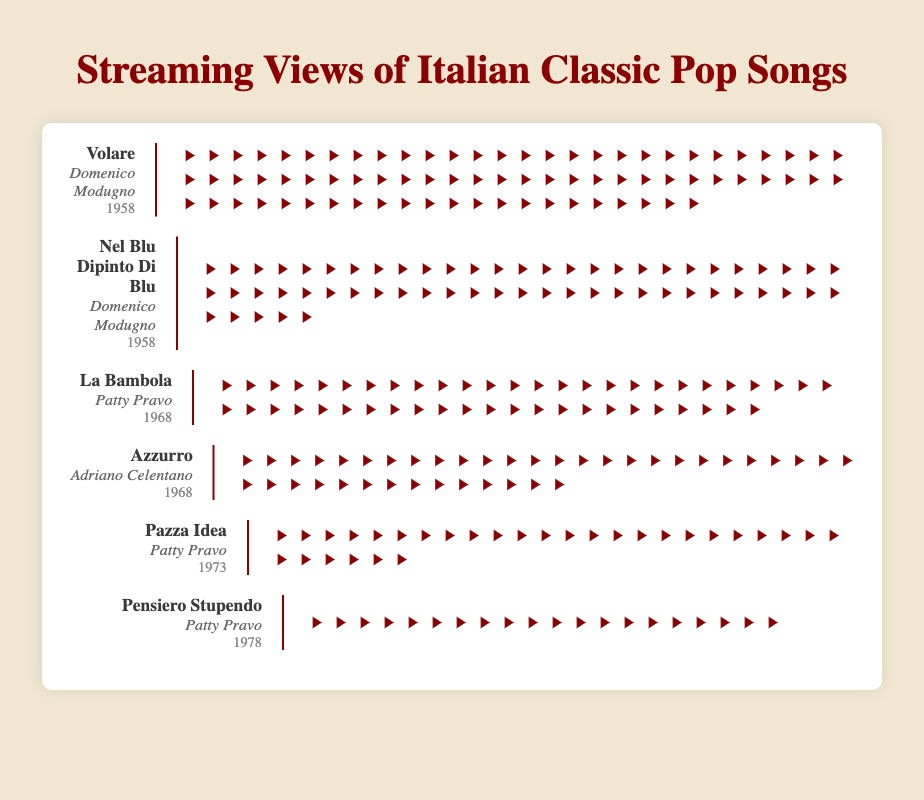How many play button icons represent views for "La Bambola"? The play button icons represent individual views and are grouped together for visual count. For "La Bambola," you can simply count the number of play button icons displayed in the figure.
Answer: 50 Which song by Patty Pravo has the least number of views? You need to look at the play button icons for each song by Patty Pravo to determine which one has the least views. Comparing all her songs, "Pensiero Stupendo" has the fewest play button icons.
Answer: Pensiero Stupendo In which year were the songs "La Bambola" and "Azzurro" released? The titles, artists, and years of release are shown clearly in the song information section of each song row. Both "La Bambola" by Patty Pravo and "Azzurro" by Adriano Celentano were released in 1968.
Answer: 1968 How many more views does "Volare" have compared to "Azzurro"? "Volare" has 80 play button icons while "Azzurro" has 40. By subtracting the icons of "Azzurro" from "Volare," you get 80 - 40 = 40 more icons. Each icon represents 100,000 views. Thus, 40 × 100,000 = 4,000,000 more views.
Answer: 4,000,000 Which song has the highest number of views? By observing the number of play button icons for each song, "Volare" by Domenico Modugno has the highest count, with 80 icons.
Answer: Volare What is the total number of views for songs released in 1958? Calculate the total number of views by adding the play button icons for 1958 releases, which include "Volare" (80 icons) and "Nel Blu Dipinto Di Blu" (60 icons). In total: 80 + 60 = 140 icons. Each icon represents 100,000 views. Thus, 140 × 100,000 = 14,000,000 views.
Answer: 14,000,000 What is the average number of views for Patty Pravo's songs shown in the figure? Count each song by Patty Pravo and their respective play button icons: "La Bambola" (50), "Pazza Idea" (30), and "Pensiero Stupendo" (20). Add the icons: 50 + 30 + 20 = 100. Divide by the number of songs, 100 / 3 = 33.33 icons, equivalent to 3,333,333 views on average.
Answer: 3,333,333 Which artist has the most aggregated views? Add the total play button icons for each artist and compare. Patty Pravo has 100, Domenico Modugno has 140, and Adriano Celentano has 40. Domenico Modugno has the most with 140 icons.
Answer: Domenico Modugno Is "Pensiero Stupendo" more popular than "Pazza Idea"? Compare their play button icon counts: "Pensiero Stupendo" has 20 while "Pazza Idea" has 30. Therefore, "Pazza Idea" has more views than "Pensiero Stupendo".
Answer: No 